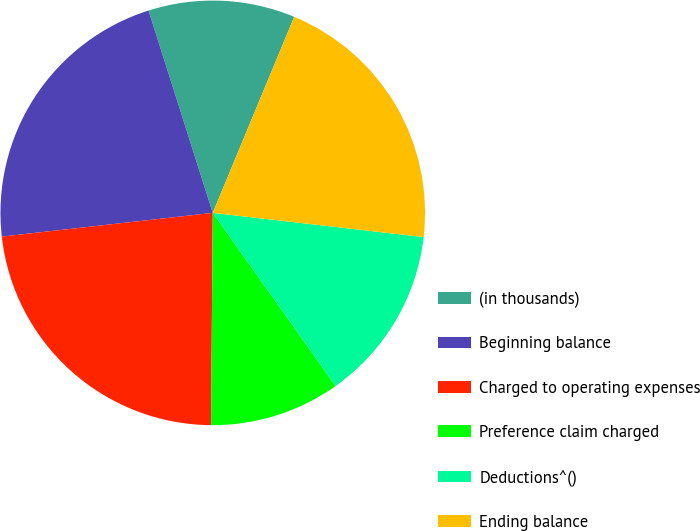Convert chart to OTSL. <chart><loc_0><loc_0><loc_500><loc_500><pie_chart><fcel>(in thousands)<fcel>Beginning balance<fcel>Charged to operating expenses<fcel>Preference claim charged<fcel>Deductions^()<fcel>Ending balance<nl><fcel>11.16%<fcel>21.89%<fcel>23.09%<fcel>9.95%<fcel>13.36%<fcel>20.55%<nl></chart> 